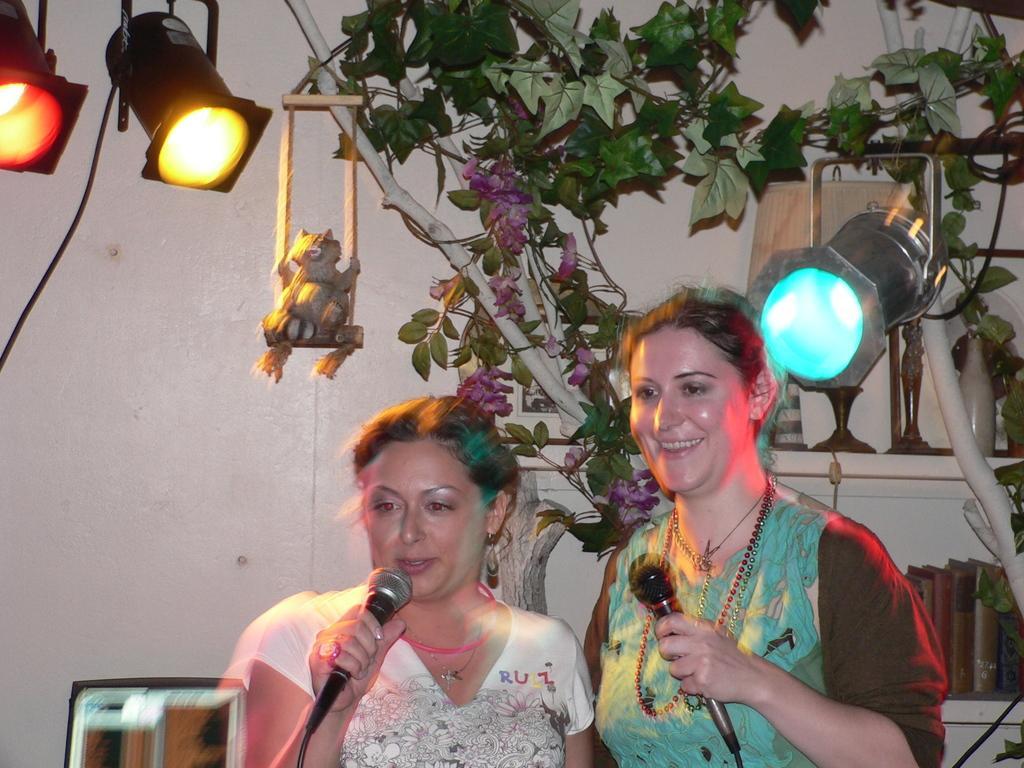Can you describe this image briefly? In this image, in the middle, we can see two women standing and holding a microphone in their hands. In the background, we can see some trees, lights, wall, we can also see some books and toys on the shelf. 